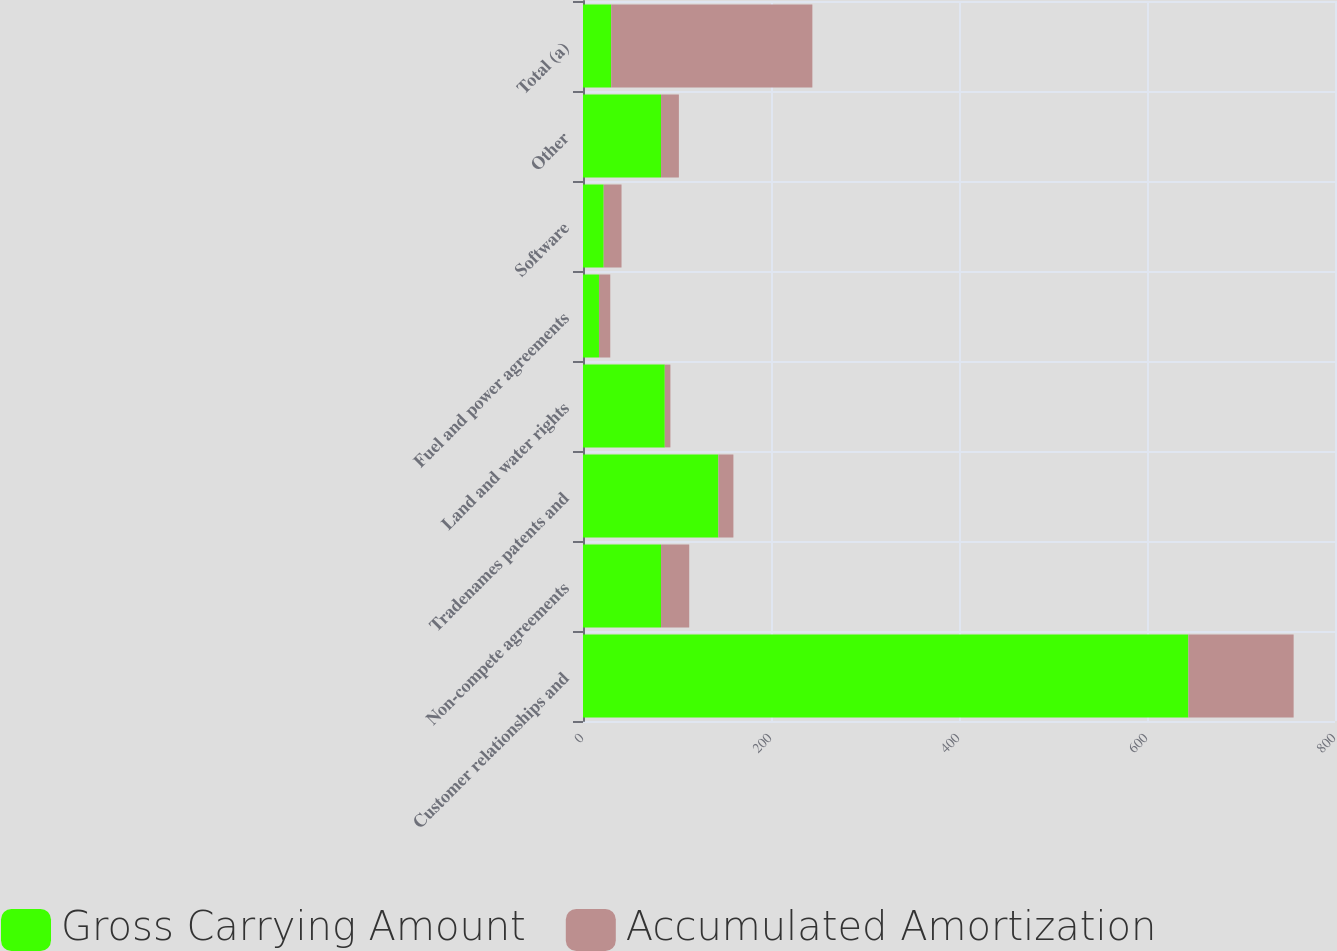Convert chart. <chart><loc_0><loc_0><loc_500><loc_500><stacked_bar_chart><ecel><fcel>Customer relationships and<fcel>Non-compete agreements<fcel>Tradenames patents and<fcel>Land and water rights<fcel>Fuel and power agreements<fcel>Software<fcel>Other<fcel>Total (a)<nl><fcel>Gross Carrying Amount<fcel>644<fcel>83<fcel>144<fcel>87<fcel>17<fcel>22<fcel>83<fcel>30<nl><fcel>Accumulated Amortization<fcel>112<fcel>30<fcel>16<fcel>6<fcel>12<fcel>19<fcel>19<fcel>214<nl></chart> 